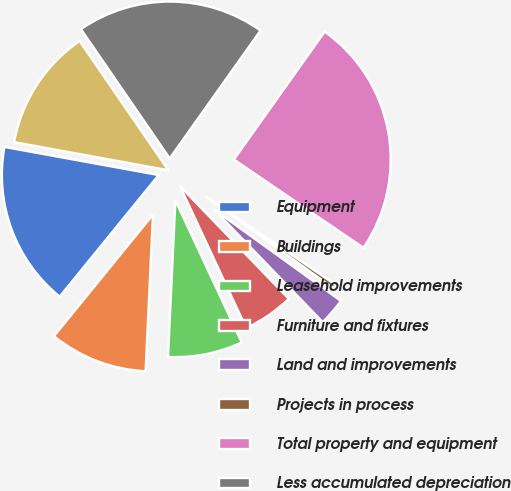Convert chart to OTSL. <chart><loc_0><loc_0><loc_500><loc_500><pie_chart><fcel>Equipment<fcel>Buildings<fcel>Leasehold improvements<fcel>Furniture and fixtures<fcel>Land and improvements<fcel>Projects in process<fcel>Total property and equipment<fcel>Less accumulated depreciation<fcel>Property and equipment net<nl><fcel>16.99%<fcel>10.13%<fcel>7.7%<fcel>5.27%<fcel>2.84%<fcel>0.42%<fcel>24.69%<fcel>19.41%<fcel>12.55%<nl></chart> 